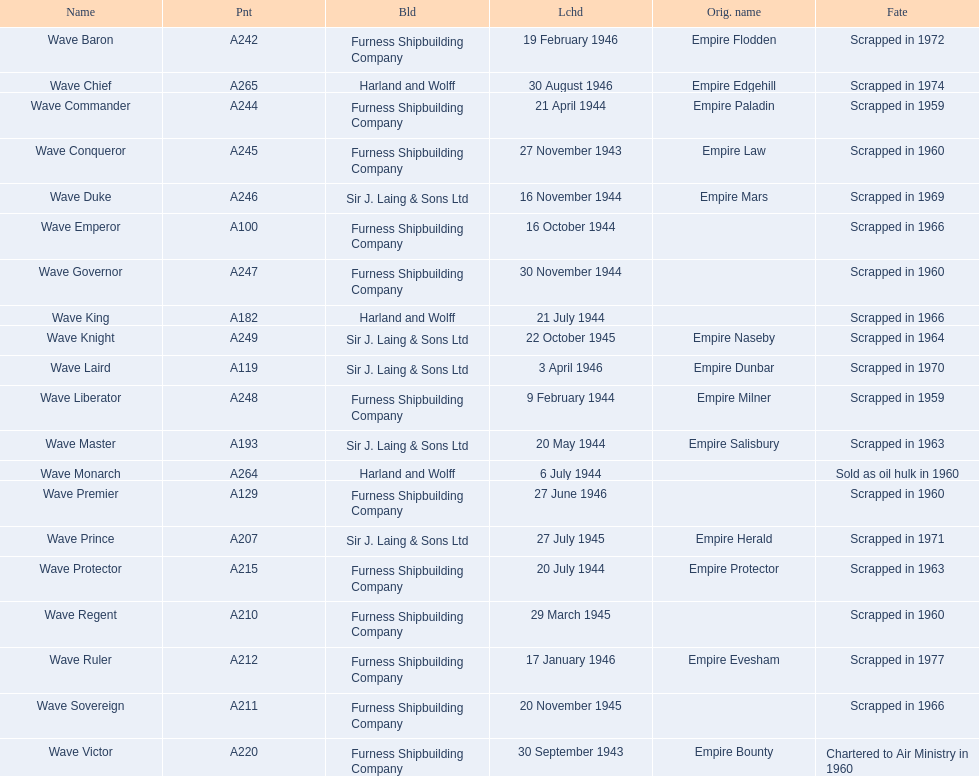What builders launched ships in november of any year? Furness Shipbuilding Company, Sir J. Laing & Sons Ltd, Furness Shipbuilding Company, Furness Shipbuilding Company. What ship builders ships had their original name's changed prior to scrapping? Furness Shipbuilding Company, Sir J. Laing & Sons Ltd. What was the name of the ship that was built in november and had its name changed prior to scrapping only 12 years after its launch? Wave Conqueror. 